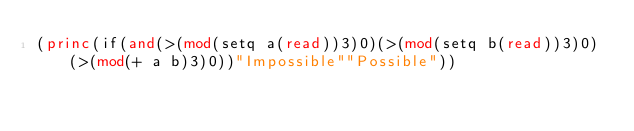Convert code to text. <code><loc_0><loc_0><loc_500><loc_500><_Lisp_>(princ(if(and(>(mod(setq a(read))3)0)(>(mod(setq b(read))3)0)(>(mod(+ a b)3)0))"Impossible""Possible"))</code> 